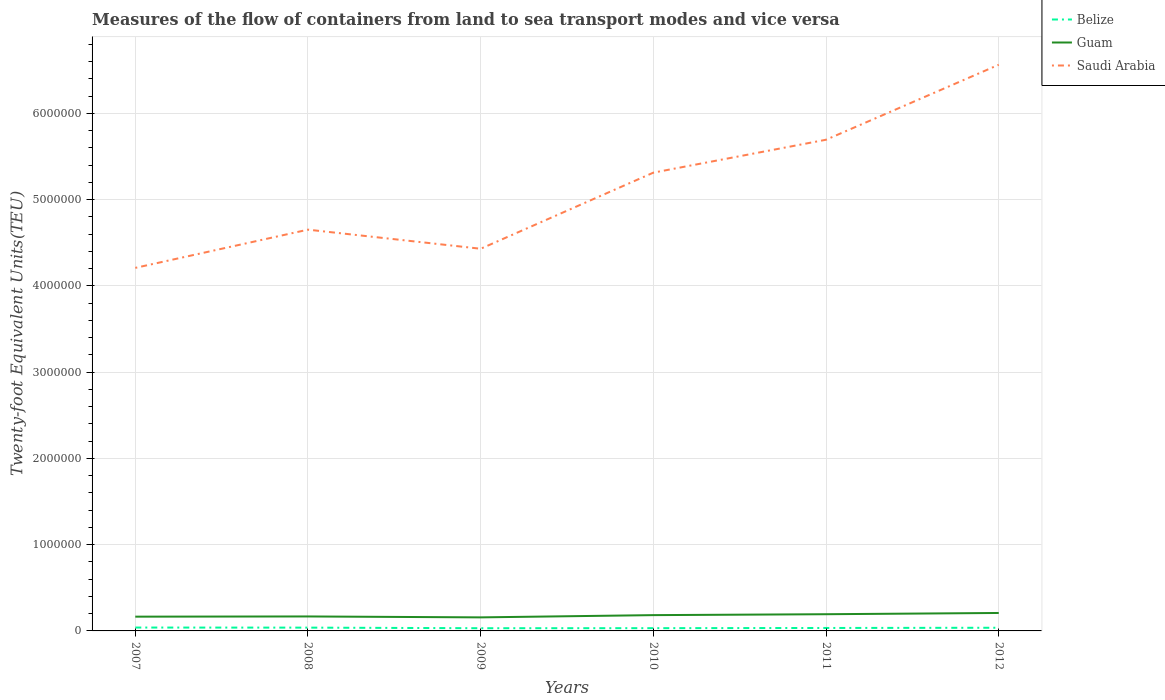Across all years, what is the maximum container port traffic in Belize?
Offer a very short reply. 3.13e+04. In which year was the container port traffic in Guam maximum?
Provide a short and direct response. 2009. What is the total container port traffic in Saudi Arabia in the graph?
Offer a very short reply. -3.81e+05. What is the difference between the highest and the second highest container port traffic in Saudi Arabia?
Make the answer very short. 2.35e+06. Is the container port traffic in Guam strictly greater than the container port traffic in Saudi Arabia over the years?
Your answer should be very brief. Yes. How many years are there in the graph?
Your response must be concise. 6. What is the difference between two consecutive major ticks on the Y-axis?
Give a very brief answer. 1.00e+06. Are the values on the major ticks of Y-axis written in scientific E-notation?
Your answer should be compact. No. Where does the legend appear in the graph?
Ensure brevity in your answer.  Top right. How are the legend labels stacked?
Offer a terse response. Vertical. What is the title of the graph?
Provide a short and direct response. Measures of the flow of containers from land to sea transport modes and vice versa. Does "Turks and Caicos Islands" appear as one of the legend labels in the graph?
Make the answer very short. No. What is the label or title of the X-axis?
Make the answer very short. Years. What is the label or title of the Y-axis?
Provide a short and direct response. Twenty-foot Equivalent Units(TEU). What is the Twenty-foot Equivalent Units(TEU) in Belize in 2007?
Your response must be concise. 3.92e+04. What is the Twenty-foot Equivalent Units(TEU) of Guam in 2007?
Give a very brief answer. 1.65e+05. What is the Twenty-foot Equivalent Units(TEU) in Saudi Arabia in 2007?
Your answer should be compact. 4.21e+06. What is the Twenty-foot Equivalent Units(TEU) of Belize in 2008?
Your answer should be compact. 3.82e+04. What is the Twenty-foot Equivalent Units(TEU) of Guam in 2008?
Offer a very short reply. 1.68e+05. What is the Twenty-foot Equivalent Units(TEU) in Saudi Arabia in 2008?
Ensure brevity in your answer.  4.65e+06. What is the Twenty-foot Equivalent Units(TEU) in Belize in 2009?
Keep it short and to the point. 3.13e+04. What is the Twenty-foot Equivalent Units(TEU) of Guam in 2009?
Your answer should be compact. 1.57e+05. What is the Twenty-foot Equivalent Units(TEU) of Saudi Arabia in 2009?
Your answer should be compact. 4.43e+06. What is the Twenty-foot Equivalent Units(TEU) of Belize in 2010?
Give a very brief answer. 3.19e+04. What is the Twenty-foot Equivalent Units(TEU) in Guam in 2010?
Offer a terse response. 1.83e+05. What is the Twenty-foot Equivalent Units(TEU) in Saudi Arabia in 2010?
Make the answer very short. 5.31e+06. What is the Twenty-foot Equivalent Units(TEU) in Belize in 2011?
Give a very brief answer. 3.42e+04. What is the Twenty-foot Equivalent Units(TEU) in Guam in 2011?
Ensure brevity in your answer.  1.94e+05. What is the Twenty-foot Equivalent Units(TEU) of Saudi Arabia in 2011?
Your answer should be very brief. 5.69e+06. What is the Twenty-foot Equivalent Units(TEU) in Belize in 2012?
Your response must be concise. 3.68e+04. What is the Twenty-foot Equivalent Units(TEU) in Guam in 2012?
Ensure brevity in your answer.  2.08e+05. What is the Twenty-foot Equivalent Units(TEU) in Saudi Arabia in 2012?
Provide a short and direct response. 6.56e+06. Across all years, what is the maximum Twenty-foot Equivalent Units(TEU) of Belize?
Make the answer very short. 3.92e+04. Across all years, what is the maximum Twenty-foot Equivalent Units(TEU) of Guam?
Ensure brevity in your answer.  2.08e+05. Across all years, what is the maximum Twenty-foot Equivalent Units(TEU) of Saudi Arabia?
Keep it short and to the point. 6.56e+06. Across all years, what is the minimum Twenty-foot Equivalent Units(TEU) of Belize?
Provide a succinct answer. 3.13e+04. Across all years, what is the minimum Twenty-foot Equivalent Units(TEU) of Guam?
Offer a very short reply. 1.57e+05. Across all years, what is the minimum Twenty-foot Equivalent Units(TEU) in Saudi Arabia?
Offer a terse response. 4.21e+06. What is the total Twenty-foot Equivalent Units(TEU) of Belize in the graph?
Provide a succinct answer. 2.12e+05. What is the total Twenty-foot Equivalent Units(TEU) in Guam in the graph?
Your answer should be compact. 1.08e+06. What is the total Twenty-foot Equivalent Units(TEU) in Saudi Arabia in the graph?
Make the answer very short. 3.09e+07. What is the difference between the Twenty-foot Equivalent Units(TEU) of Belize in 2007 and that in 2008?
Your response must be concise. 980. What is the difference between the Twenty-foot Equivalent Units(TEU) in Guam in 2007 and that in 2008?
Provide a succinct answer. -2357. What is the difference between the Twenty-foot Equivalent Units(TEU) in Saudi Arabia in 2007 and that in 2008?
Keep it short and to the point. -4.43e+05. What is the difference between the Twenty-foot Equivalent Units(TEU) in Belize in 2007 and that in 2009?
Offer a terse response. 7847. What is the difference between the Twenty-foot Equivalent Units(TEU) in Guam in 2007 and that in 2009?
Provide a short and direct response. 8331. What is the difference between the Twenty-foot Equivalent Units(TEU) in Saudi Arabia in 2007 and that in 2009?
Offer a very short reply. -2.22e+05. What is the difference between the Twenty-foot Equivalent Units(TEU) in Belize in 2007 and that in 2010?
Your response must be concise. 7272. What is the difference between the Twenty-foot Equivalent Units(TEU) in Guam in 2007 and that in 2010?
Give a very brief answer. -1.78e+04. What is the difference between the Twenty-foot Equivalent Units(TEU) of Saudi Arabia in 2007 and that in 2010?
Provide a short and direct response. -1.10e+06. What is the difference between the Twenty-foot Equivalent Units(TEU) of Belize in 2007 and that in 2011?
Ensure brevity in your answer.  4991. What is the difference between the Twenty-foot Equivalent Units(TEU) of Guam in 2007 and that in 2011?
Your response must be concise. -2.82e+04. What is the difference between the Twenty-foot Equivalent Units(TEU) in Saudi Arabia in 2007 and that in 2011?
Provide a short and direct response. -1.49e+06. What is the difference between the Twenty-foot Equivalent Units(TEU) of Belize in 2007 and that in 2012?
Make the answer very short. 2426. What is the difference between the Twenty-foot Equivalent Units(TEU) in Guam in 2007 and that in 2012?
Offer a terse response. -4.28e+04. What is the difference between the Twenty-foot Equivalent Units(TEU) of Saudi Arabia in 2007 and that in 2012?
Ensure brevity in your answer.  -2.35e+06. What is the difference between the Twenty-foot Equivalent Units(TEU) of Belize in 2008 and that in 2009?
Provide a succinct answer. 6867. What is the difference between the Twenty-foot Equivalent Units(TEU) in Guam in 2008 and that in 2009?
Offer a terse response. 1.07e+04. What is the difference between the Twenty-foot Equivalent Units(TEU) in Saudi Arabia in 2008 and that in 2009?
Provide a succinct answer. 2.21e+05. What is the difference between the Twenty-foot Equivalent Units(TEU) of Belize in 2008 and that in 2010?
Your response must be concise. 6292. What is the difference between the Twenty-foot Equivalent Units(TEU) in Guam in 2008 and that in 2010?
Provide a short and direct response. -1.54e+04. What is the difference between the Twenty-foot Equivalent Units(TEU) of Saudi Arabia in 2008 and that in 2010?
Your response must be concise. -6.61e+05. What is the difference between the Twenty-foot Equivalent Units(TEU) of Belize in 2008 and that in 2011?
Make the answer very short. 4011. What is the difference between the Twenty-foot Equivalent Units(TEU) of Guam in 2008 and that in 2011?
Keep it short and to the point. -2.59e+04. What is the difference between the Twenty-foot Equivalent Units(TEU) of Saudi Arabia in 2008 and that in 2011?
Keep it short and to the point. -1.04e+06. What is the difference between the Twenty-foot Equivalent Units(TEU) of Belize in 2008 and that in 2012?
Ensure brevity in your answer.  1446. What is the difference between the Twenty-foot Equivalent Units(TEU) of Guam in 2008 and that in 2012?
Keep it short and to the point. -4.04e+04. What is the difference between the Twenty-foot Equivalent Units(TEU) in Saudi Arabia in 2008 and that in 2012?
Your answer should be very brief. -1.91e+06. What is the difference between the Twenty-foot Equivalent Units(TEU) of Belize in 2009 and that in 2010?
Your answer should be compact. -575. What is the difference between the Twenty-foot Equivalent Units(TEU) of Guam in 2009 and that in 2010?
Offer a terse response. -2.61e+04. What is the difference between the Twenty-foot Equivalent Units(TEU) in Saudi Arabia in 2009 and that in 2010?
Your response must be concise. -8.82e+05. What is the difference between the Twenty-foot Equivalent Units(TEU) of Belize in 2009 and that in 2011?
Make the answer very short. -2856. What is the difference between the Twenty-foot Equivalent Units(TEU) of Guam in 2009 and that in 2011?
Ensure brevity in your answer.  -3.66e+04. What is the difference between the Twenty-foot Equivalent Units(TEU) in Saudi Arabia in 2009 and that in 2011?
Provide a short and direct response. -1.26e+06. What is the difference between the Twenty-foot Equivalent Units(TEU) of Belize in 2009 and that in 2012?
Your answer should be compact. -5421. What is the difference between the Twenty-foot Equivalent Units(TEU) of Guam in 2009 and that in 2012?
Offer a terse response. -5.11e+04. What is the difference between the Twenty-foot Equivalent Units(TEU) of Saudi Arabia in 2009 and that in 2012?
Make the answer very short. -2.13e+06. What is the difference between the Twenty-foot Equivalent Units(TEU) of Belize in 2010 and that in 2011?
Offer a terse response. -2281. What is the difference between the Twenty-foot Equivalent Units(TEU) in Guam in 2010 and that in 2011?
Make the answer very short. -1.04e+04. What is the difference between the Twenty-foot Equivalent Units(TEU) of Saudi Arabia in 2010 and that in 2011?
Make the answer very short. -3.81e+05. What is the difference between the Twenty-foot Equivalent Units(TEU) of Belize in 2010 and that in 2012?
Give a very brief answer. -4846. What is the difference between the Twenty-foot Equivalent Units(TEU) of Guam in 2010 and that in 2012?
Keep it short and to the point. -2.50e+04. What is the difference between the Twenty-foot Equivalent Units(TEU) in Saudi Arabia in 2010 and that in 2012?
Your answer should be compact. -1.25e+06. What is the difference between the Twenty-foot Equivalent Units(TEU) of Belize in 2011 and that in 2012?
Offer a terse response. -2565. What is the difference between the Twenty-foot Equivalent Units(TEU) in Guam in 2011 and that in 2012?
Your response must be concise. -1.45e+04. What is the difference between the Twenty-foot Equivalent Units(TEU) of Saudi Arabia in 2011 and that in 2012?
Ensure brevity in your answer.  -8.69e+05. What is the difference between the Twenty-foot Equivalent Units(TEU) in Belize in 2007 and the Twenty-foot Equivalent Units(TEU) in Guam in 2008?
Your response must be concise. -1.29e+05. What is the difference between the Twenty-foot Equivalent Units(TEU) in Belize in 2007 and the Twenty-foot Equivalent Units(TEU) in Saudi Arabia in 2008?
Offer a very short reply. -4.61e+06. What is the difference between the Twenty-foot Equivalent Units(TEU) in Guam in 2007 and the Twenty-foot Equivalent Units(TEU) in Saudi Arabia in 2008?
Provide a succinct answer. -4.49e+06. What is the difference between the Twenty-foot Equivalent Units(TEU) in Belize in 2007 and the Twenty-foot Equivalent Units(TEU) in Guam in 2009?
Make the answer very short. -1.18e+05. What is the difference between the Twenty-foot Equivalent Units(TEU) in Belize in 2007 and the Twenty-foot Equivalent Units(TEU) in Saudi Arabia in 2009?
Give a very brief answer. -4.39e+06. What is the difference between the Twenty-foot Equivalent Units(TEU) in Guam in 2007 and the Twenty-foot Equivalent Units(TEU) in Saudi Arabia in 2009?
Provide a succinct answer. -4.27e+06. What is the difference between the Twenty-foot Equivalent Units(TEU) of Belize in 2007 and the Twenty-foot Equivalent Units(TEU) of Guam in 2010?
Give a very brief answer. -1.44e+05. What is the difference between the Twenty-foot Equivalent Units(TEU) of Belize in 2007 and the Twenty-foot Equivalent Units(TEU) of Saudi Arabia in 2010?
Your response must be concise. -5.27e+06. What is the difference between the Twenty-foot Equivalent Units(TEU) in Guam in 2007 and the Twenty-foot Equivalent Units(TEU) in Saudi Arabia in 2010?
Your response must be concise. -5.15e+06. What is the difference between the Twenty-foot Equivalent Units(TEU) in Belize in 2007 and the Twenty-foot Equivalent Units(TEU) in Guam in 2011?
Ensure brevity in your answer.  -1.54e+05. What is the difference between the Twenty-foot Equivalent Units(TEU) of Belize in 2007 and the Twenty-foot Equivalent Units(TEU) of Saudi Arabia in 2011?
Give a very brief answer. -5.66e+06. What is the difference between the Twenty-foot Equivalent Units(TEU) of Guam in 2007 and the Twenty-foot Equivalent Units(TEU) of Saudi Arabia in 2011?
Your answer should be very brief. -5.53e+06. What is the difference between the Twenty-foot Equivalent Units(TEU) in Belize in 2007 and the Twenty-foot Equivalent Units(TEU) in Guam in 2012?
Offer a terse response. -1.69e+05. What is the difference between the Twenty-foot Equivalent Units(TEU) of Belize in 2007 and the Twenty-foot Equivalent Units(TEU) of Saudi Arabia in 2012?
Your response must be concise. -6.52e+06. What is the difference between the Twenty-foot Equivalent Units(TEU) of Guam in 2007 and the Twenty-foot Equivalent Units(TEU) of Saudi Arabia in 2012?
Provide a succinct answer. -6.40e+06. What is the difference between the Twenty-foot Equivalent Units(TEU) of Belize in 2008 and the Twenty-foot Equivalent Units(TEU) of Guam in 2009?
Ensure brevity in your answer.  -1.19e+05. What is the difference between the Twenty-foot Equivalent Units(TEU) of Belize in 2008 and the Twenty-foot Equivalent Units(TEU) of Saudi Arabia in 2009?
Keep it short and to the point. -4.39e+06. What is the difference between the Twenty-foot Equivalent Units(TEU) in Guam in 2008 and the Twenty-foot Equivalent Units(TEU) in Saudi Arabia in 2009?
Make the answer very short. -4.26e+06. What is the difference between the Twenty-foot Equivalent Units(TEU) in Belize in 2008 and the Twenty-foot Equivalent Units(TEU) in Guam in 2010?
Provide a succinct answer. -1.45e+05. What is the difference between the Twenty-foot Equivalent Units(TEU) in Belize in 2008 and the Twenty-foot Equivalent Units(TEU) in Saudi Arabia in 2010?
Offer a very short reply. -5.27e+06. What is the difference between the Twenty-foot Equivalent Units(TEU) of Guam in 2008 and the Twenty-foot Equivalent Units(TEU) of Saudi Arabia in 2010?
Offer a very short reply. -5.15e+06. What is the difference between the Twenty-foot Equivalent Units(TEU) of Belize in 2008 and the Twenty-foot Equivalent Units(TEU) of Guam in 2011?
Your answer should be very brief. -1.55e+05. What is the difference between the Twenty-foot Equivalent Units(TEU) of Belize in 2008 and the Twenty-foot Equivalent Units(TEU) of Saudi Arabia in 2011?
Offer a very short reply. -5.66e+06. What is the difference between the Twenty-foot Equivalent Units(TEU) of Guam in 2008 and the Twenty-foot Equivalent Units(TEU) of Saudi Arabia in 2011?
Your answer should be compact. -5.53e+06. What is the difference between the Twenty-foot Equivalent Units(TEU) in Belize in 2008 and the Twenty-foot Equivalent Units(TEU) in Guam in 2012?
Provide a short and direct response. -1.70e+05. What is the difference between the Twenty-foot Equivalent Units(TEU) in Belize in 2008 and the Twenty-foot Equivalent Units(TEU) in Saudi Arabia in 2012?
Offer a terse response. -6.53e+06. What is the difference between the Twenty-foot Equivalent Units(TEU) of Guam in 2008 and the Twenty-foot Equivalent Units(TEU) of Saudi Arabia in 2012?
Provide a succinct answer. -6.40e+06. What is the difference between the Twenty-foot Equivalent Units(TEU) of Belize in 2009 and the Twenty-foot Equivalent Units(TEU) of Guam in 2010?
Your response must be concise. -1.52e+05. What is the difference between the Twenty-foot Equivalent Units(TEU) in Belize in 2009 and the Twenty-foot Equivalent Units(TEU) in Saudi Arabia in 2010?
Make the answer very short. -5.28e+06. What is the difference between the Twenty-foot Equivalent Units(TEU) in Guam in 2009 and the Twenty-foot Equivalent Units(TEU) in Saudi Arabia in 2010?
Your answer should be very brief. -5.16e+06. What is the difference between the Twenty-foot Equivalent Units(TEU) of Belize in 2009 and the Twenty-foot Equivalent Units(TEU) of Guam in 2011?
Provide a succinct answer. -1.62e+05. What is the difference between the Twenty-foot Equivalent Units(TEU) of Belize in 2009 and the Twenty-foot Equivalent Units(TEU) of Saudi Arabia in 2011?
Your response must be concise. -5.66e+06. What is the difference between the Twenty-foot Equivalent Units(TEU) in Guam in 2009 and the Twenty-foot Equivalent Units(TEU) in Saudi Arabia in 2011?
Your answer should be compact. -5.54e+06. What is the difference between the Twenty-foot Equivalent Units(TEU) of Belize in 2009 and the Twenty-foot Equivalent Units(TEU) of Guam in 2012?
Your answer should be compact. -1.77e+05. What is the difference between the Twenty-foot Equivalent Units(TEU) of Belize in 2009 and the Twenty-foot Equivalent Units(TEU) of Saudi Arabia in 2012?
Offer a terse response. -6.53e+06. What is the difference between the Twenty-foot Equivalent Units(TEU) in Guam in 2009 and the Twenty-foot Equivalent Units(TEU) in Saudi Arabia in 2012?
Ensure brevity in your answer.  -6.41e+06. What is the difference between the Twenty-foot Equivalent Units(TEU) of Belize in 2010 and the Twenty-foot Equivalent Units(TEU) of Guam in 2011?
Provide a succinct answer. -1.62e+05. What is the difference between the Twenty-foot Equivalent Units(TEU) of Belize in 2010 and the Twenty-foot Equivalent Units(TEU) of Saudi Arabia in 2011?
Provide a succinct answer. -5.66e+06. What is the difference between the Twenty-foot Equivalent Units(TEU) of Guam in 2010 and the Twenty-foot Equivalent Units(TEU) of Saudi Arabia in 2011?
Your answer should be compact. -5.51e+06. What is the difference between the Twenty-foot Equivalent Units(TEU) in Belize in 2010 and the Twenty-foot Equivalent Units(TEU) in Guam in 2012?
Keep it short and to the point. -1.76e+05. What is the difference between the Twenty-foot Equivalent Units(TEU) in Belize in 2010 and the Twenty-foot Equivalent Units(TEU) in Saudi Arabia in 2012?
Offer a terse response. -6.53e+06. What is the difference between the Twenty-foot Equivalent Units(TEU) in Guam in 2010 and the Twenty-foot Equivalent Units(TEU) in Saudi Arabia in 2012?
Your response must be concise. -6.38e+06. What is the difference between the Twenty-foot Equivalent Units(TEU) in Belize in 2011 and the Twenty-foot Equivalent Units(TEU) in Guam in 2012?
Offer a very short reply. -1.74e+05. What is the difference between the Twenty-foot Equivalent Units(TEU) of Belize in 2011 and the Twenty-foot Equivalent Units(TEU) of Saudi Arabia in 2012?
Ensure brevity in your answer.  -6.53e+06. What is the difference between the Twenty-foot Equivalent Units(TEU) of Guam in 2011 and the Twenty-foot Equivalent Units(TEU) of Saudi Arabia in 2012?
Provide a short and direct response. -6.37e+06. What is the average Twenty-foot Equivalent Units(TEU) in Belize per year?
Offer a terse response. 3.53e+04. What is the average Twenty-foot Equivalent Units(TEU) in Guam per year?
Provide a short and direct response. 1.79e+05. What is the average Twenty-foot Equivalent Units(TEU) of Saudi Arabia per year?
Provide a succinct answer. 5.14e+06. In the year 2007, what is the difference between the Twenty-foot Equivalent Units(TEU) of Belize and Twenty-foot Equivalent Units(TEU) of Guam?
Ensure brevity in your answer.  -1.26e+05. In the year 2007, what is the difference between the Twenty-foot Equivalent Units(TEU) of Belize and Twenty-foot Equivalent Units(TEU) of Saudi Arabia?
Keep it short and to the point. -4.17e+06. In the year 2007, what is the difference between the Twenty-foot Equivalent Units(TEU) of Guam and Twenty-foot Equivalent Units(TEU) of Saudi Arabia?
Your response must be concise. -4.04e+06. In the year 2008, what is the difference between the Twenty-foot Equivalent Units(TEU) in Belize and Twenty-foot Equivalent Units(TEU) in Guam?
Ensure brevity in your answer.  -1.30e+05. In the year 2008, what is the difference between the Twenty-foot Equivalent Units(TEU) in Belize and Twenty-foot Equivalent Units(TEU) in Saudi Arabia?
Provide a short and direct response. -4.61e+06. In the year 2008, what is the difference between the Twenty-foot Equivalent Units(TEU) of Guam and Twenty-foot Equivalent Units(TEU) of Saudi Arabia?
Your answer should be very brief. -4.48e+06. In the year 2009, what is the difference between the Twenty-foot Equivalent Units(TEU) in Belize and Twenty-foot Equivalent Units(TEU) in Guam?
Offer a very short reply. -1.26e+05. In the year 2009, what is the difference between the Twenty-foot Equivalent Units(TEU) of Belize and Twenty-foot Equivalent Units(TEU) of Saudi Arabia?
Your response must be concise. -4.40e+06. In the year 2009, what is the difference between the Twenty-foot Equivalent Units(TEU) in Guam and Twenty-foot Equivalent Units(TEU) in Saudi Arabia?
Your answer should be very brief. -4.27e+06. In the year 2010, what is the difference between the Twenty-foot Equivalent Units(TEU) in Belize and Twenty-foot Equivalent Units(TEU) in Guam?
Provide a short and direct response. -1.51e+05. In the year 2010, what is the difference between the Twenty-foot Equivalent Units(TEU) in Belize and Twenty-foot Equivalent Units(TEU) in Saudi Arabia?
Provide a short and direct response. -5.28e+06. In the year 2010, what is the difference between the Twenty-foot Equivalent Units(TEU) of Guam and Twenty-foot Equivalent Units(TEU) of Saudi Arabia?
Provide a short and direct response. -5.13e+06. In the year 2011, what is the difference between the Twenty-foot Equivalent Units(TEU) in Belize and Twenty-foot Equivalent Units(TEU) in Guam?
Your answer should be compact. -1.59e+05. In the year 2011, what is the difference between the Twenty-foot Equivalent Units(TEU) of Belize and Twenty-foot Equivalent Units(TEU) of Saudi Arabia?
Your answer should be very brief. -5.66e+06. In the year 2011, what is the difference between the Twenty-foot Equivalent Units(TEU) of Guam and Twenty-foot Equivalent Units(TEU) of Saudi Arabia?
Your answer should be compact. -5.50e+06. In the year 2012, what is the difference between the Twenty-foot Equivalent Units(TEU) in Belize and Twenty-foot Equivalent Units(TEU) in Guam?
Your answer should be very brief. -1.71e+05. In the year 2012, what is the difference between the Twenty-foot Equivalent Units(TEU) of Belize and Twenty-foot Equivalent Units(TEU) of Saudi Arabia?
Provide a succinct answer. -6.53e+06. In the year 2012, what is the difference between the Twenty-foot Equivalent Units(TEU) in Guam and Twenty-foot Equivalent Units(TEU) in Saudi Arabia?
Ensure brevity in your answer.  -6.36e+06. What is the ratio of the Twenty-foot Equivalent Units(TEU) in Belize in 2007 to that in 2008?
Make the answer very short. 1.03. What is the ratio of the Twenty-foot Equivalent Units(TEU) in Saudi Arabia in 2007 to that in 2008?
Give a very brief answer. 0.9. What is the ratio of the Twenty-foot Equivalent Units(TEU) of Belize in 2007 to that in 2009?
Offer a terse response. 1.25. What is the ratio of the Twenty-foot Equivalent Units(TEU) of Guam in 2007 to that in 2009?
Keep it short and to the point. 1.05. What is the ratio of the Twenty-foot Equivalent Units(TEU) of Saudi Arabia in 2007 to that in 2009?
Ensure brevity in your answer.  0.95. What is the ratio of the Twenty-foot Equivalent Units(TEU) in Belize in 2007 to that in 2010?
Make the answer very short. 1.23. What is the ratio of the Twenty-foot Equivalent Units(TEU) in Guam in 2007 to that in 2010?
Provide a succinct answer. 0.9. What is the ratio of the Twenty-foot Equivalent Units(TEU) in Saudi Arabia in 2007 to that in 2010?
Make the answer very short. 0.79. What is the ratio of the Twenty-foot Equivalent Units(TEU) of Belize in 2007 to that in 2011?
Give a very brief answer. 1.15. What is the ratio of the Twenty-foot Equivalent Units(TEU) of Guam in 2007 to that in 2011?
Keep it short and to the point. 0.85. What is the ratio of the Twenty-foot Equivalent Units(TEU) in Saudi Arabia in 2007 to that in 2011?
Offer a very short reply. 0.74. What is the ratio of the Twenty-foot Equivalent Units(TEU) of Belize in 2007 to that in 2012?
Provide a short and direct response. 1.07. What is the ratio of the Twenty-foot Equivalent Units(TEU) of Guam in 2007 to that in 2012?
Keep it short and to the point. 0.79. What is the ratio of the Twenty-foot Equivalent Units(TEU) of Saudi Arabia in 2007 to that in 2012?
Keep it short and to the point. 0.64. What is the ratio of the Twenty-foot Equivalent Units(TEU) in Belize in 2008 to that in 2009?
Offer a terse response. 1.22. What is the ratio of the Twenty-foot Equivalent Units(TEU) in Guam in 2008 to that in 2009?
Your answer should be very brief. 1.07. What is the ratio of the Twenty-foot Equivalent Units(TEU) of Belize in 2008 to that in 2010?
Your response must be concise. 1.2. What is the ratio of the Twenty-foot Equivalent Units(TEU) in Guam in 2008 to that in 2010?
Your answer should be very brief. 0.92. What is the ratio of the Twenty-foot Equivalent Units(TEU) in Saudi Arabia in 2008 to that in 2010?
Offer a terse response. 0.88. What is the ratio of the Twenty-foot Equivalent Units(TEU) in Belize in 2008 to that in 2011?
Keep it short and to the point. 1.12. What is the ratio of the Twenty-foot Equivalent Units(TEU) in Guam in 2008 to that in 2011?
Provide a short and direct response. 0.87. What is the ratio of the Twenty-foot Equivalent Units(TEU) of Saudi Arabia in 2008 to that in 2011?
Offer a terse response. 0.82. What is the ratio of the Twenty-foot Equivalent Units(TEU) of Belize in 2008 to that in 2012?
Ensure brevity in your answer.  1.04. What is the ratio of the Twenty-foot Equivalent Units(TEU) of Guam in 2008 to that in 2012?
Make the answer very short. 0.81. What is the ratio of the Twenty-foot Equivalent Units(TEU) in Saudi Arabia in 2008 to that in 2012?
Your answer should be very brief. 0.71. What is the ratio of the Twenty-foot Equivalent Units(TEU) of Belize in 2009 to that in 2010?
Your response must be concise. 0.98. What is the ratio of the Twenty-foot Equivalent Units(TEU) in Guam in 2009 to that in 2010?
Keep it short and to the point. 0.86. What is the ratio of the Twenty-foot Equivalent Units(TEU) in Saudi Arabia in 2009 to that in 2010?
Give a very brief answer. 0.83. What is the ratio of the Twenty-foot Equivalent Units(TEU) in Belize in 2009 to that in 2011?
Make the answer very short. 0.92. What is the ratio of the Twenty-foot Equivalent Units(TEU) in Guam in 2009 to that in 2011?
Provide a succinct answer. 0.81. What is the ratio of the Twenty-foot Equivalent Units(TEU) of Saudi Arabia in 2009 to that in 2011?
Make the answer very short. 0.78. What is the ratio of the Twenty-foot Equivalent Units(TEU) of Belize in 2009 to that in 2012?
Provide a short and direct response. 0.85. What is the ratio of the Twenty-foot Equivalent Units(TEU) in Guam in 2009 to that in 2012?
Offer a very short reply. 0.75. What is the ratio of the Twenty-foot Equivalent Units(TEU) in Saudi Arabia in 2009 to that in 2012?
Offer a very short reply. 0.68. What is the ratio of the Twenty-foot Equivalent Units(TEU) in Belize in 2010 to that in 2011?
Ensure brevity in your answer.  0.93. What is the ratio of the Twenty-foot Equivalent Units(TEU) in Guam in 2010 to that in 2011?
Provide a succinct answer. 0.95. What is the ratio of the Twenty-foot Equivalent Units(TEU) in Saudi Arabia in 2010 to that in 2011?
Ensure brevity in your answer.  0.93. What is the ratio of the Twenty-foot Equivalent Units(TEU) in Belize in 2010 to that in 2012?
Give a very brief answer. 0.87. What is the ratio of the Twenty-foot Equivalent Units(TEU) in Guam in 2010 to that in 2012?
Your answer should be compact. 0.88. What is the ratio of the Twenty-foot Equivalent Units(TEU) in Saudi Arabia in 2010 to that in 2012?
Your answer should be very brief. 0.81. What is the ratio of the Twenty-foot Equivalent Units(TEU) in Belize in 2011 to that in 2012?
Ensure brevity in your answer.  0.93. What is the ratio of the Twenty-foot Equivalent Units(TEU) in Guam in 2011 to that in 2012?
Give a very brief answer. 0.93. What is the ratio of the Twenty-foot Equivalent Units(TEU) in Saudi Arabia in 2011 to that in 2012?
Give a very brief answer. 0.87. What is the difference between the highest and the second highest Twenty-foot Equivalent Units(TEU) of Belize?
Provide a short and direct response. 980. What is the difference between the highest and the second highest Twenty-foot Equivalent Units(TEU) in Guam?
Your answer should be very brief. 1.45e+04. What is the difference between the highest and the second highest Twenty-foot Equivalent Units(TEU) of Saudi Arabia?
Ensure brevity in your answer.  8.69e+05. What is the difference between the highest and the lowest Twenty-foot Equivalent Units(TEU) of Belize?
Provide a succinct answer. 7847. What is the difference between the highest and the lowest Twenty-foot Equivalent Units(TEU) in Guam?
Keep it short and to the point. 5.11e+04. What is the difference between the highest and the lowest Twenty-foot Equivalent Units(TEU) in Saudi Arabia?
Provide a short and direct response. 2.35e+06. 